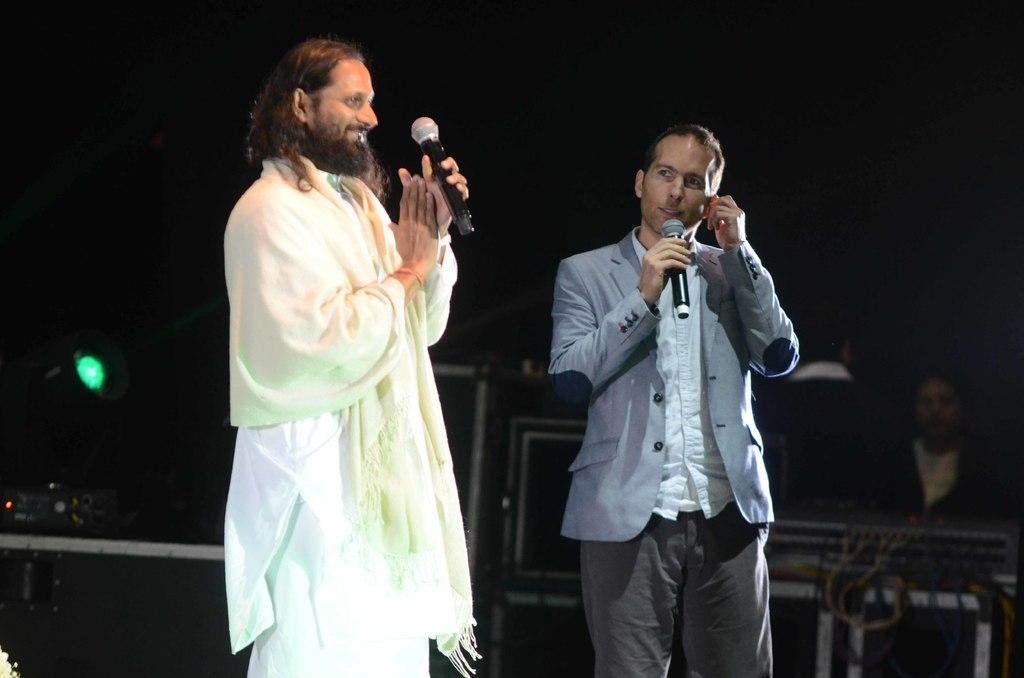How would you summarize this image in a sentence or two? There are two people standing and holding mike's. At background I can see a person sitting and these looks like some electronic devices. 